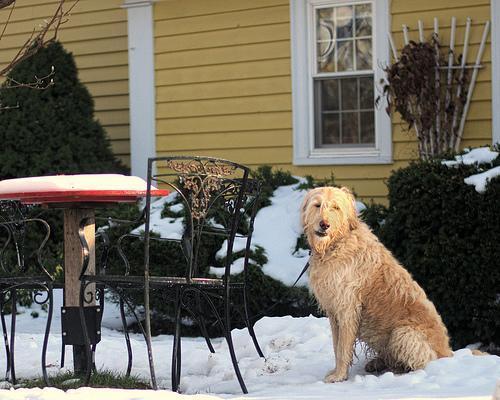How many dogs in picture?
Give a very brief answer. 1. 